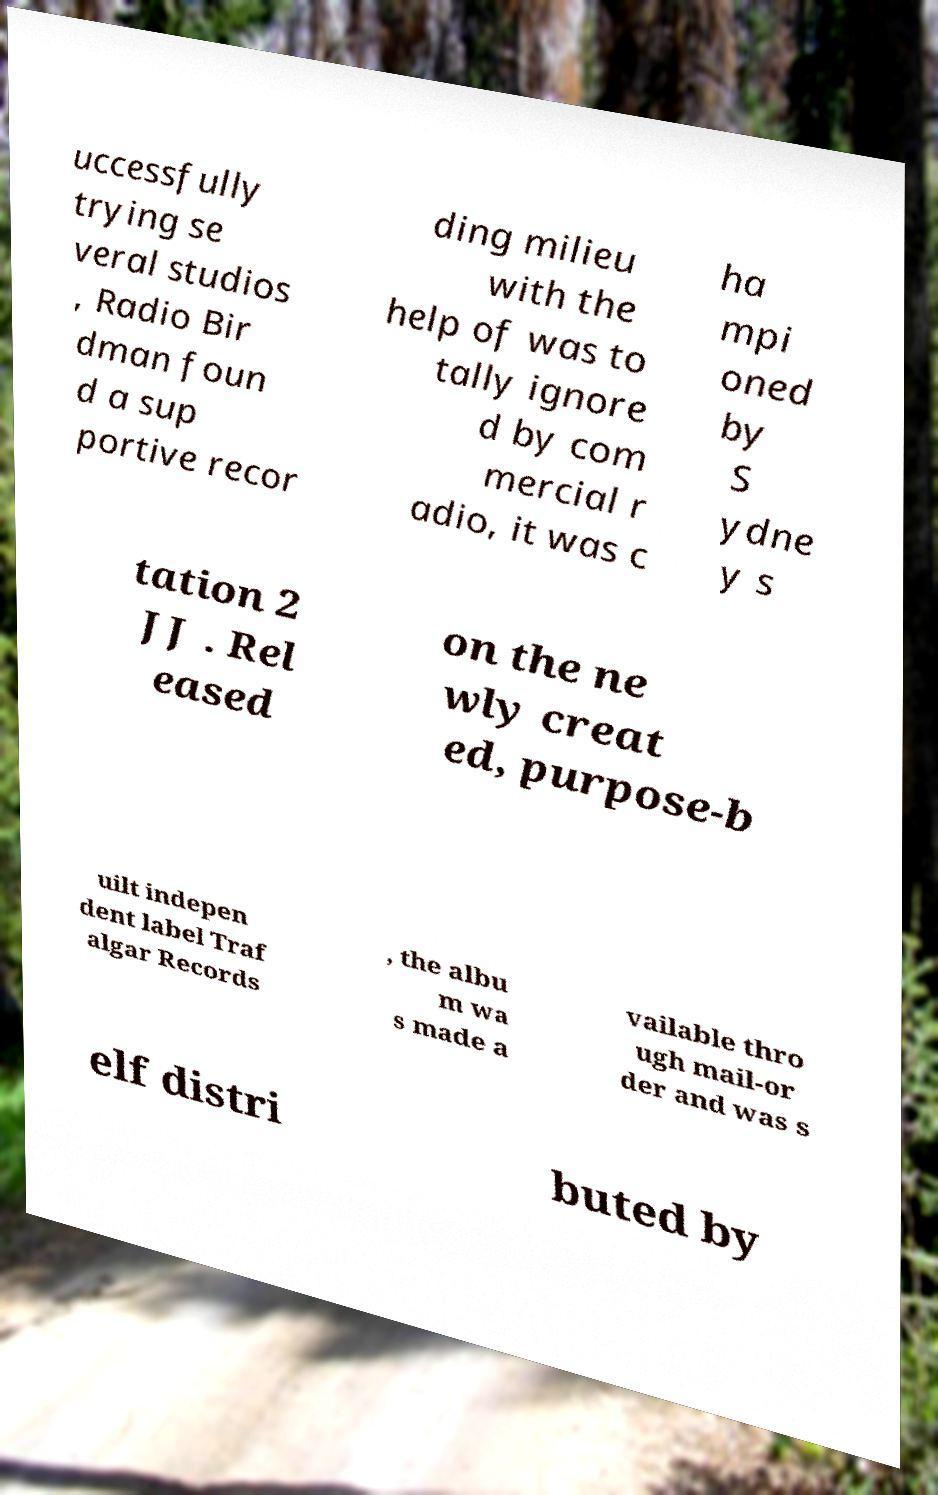I need the written content from this picture converted into text. Can you do that? uccessfully trying se veral studios , Radio Bir dman foun d a sup portive recor ding milieu with the help of was to tally ignore d by com mercial r adio, it was c ha mpi oned by S ydne y s tation 2 JJ . Rel eased on the ne wly creat ed, purpose-b uilt indepen dent label Traf algar Records , the albu m wa s made a vailable thro ugh mail-or der and was s elf distri buted by 